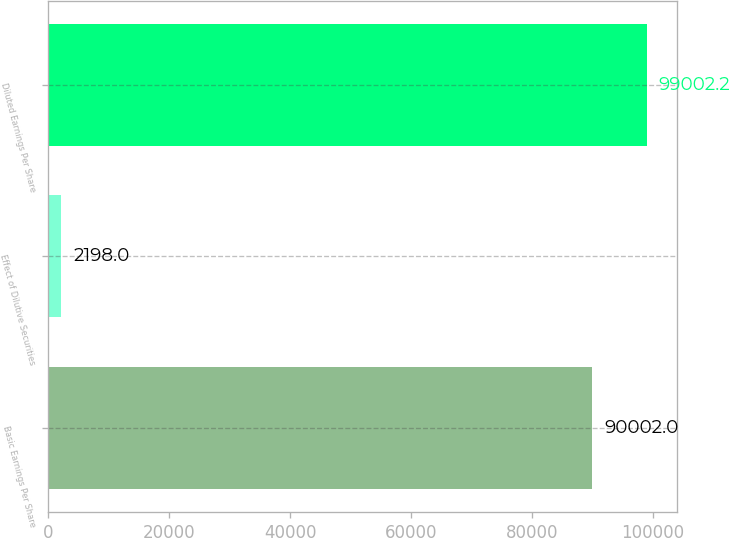<chart> <loc_0><loc_0><loc_500><loc_500><bar_chart><fcel>Basic Earnings Per Share<fcel>Effect of Dilutive Securities<fcel>Diluted Earnings Per Share<nl><fcel>90002<fcel>2198<fcel>99002.2<nl></chart> 